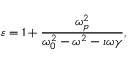Convert formula to latex. <formula><loc_0><loc_0><loc_500><loc_500>\varepsilon = 1 + \frac { \omega _ { p } ^ { 2 } } { \omega _ { 0 } ^ { 2 } - \omega ^ { 2 } - \imath \omega \gamma } ,</formula> 